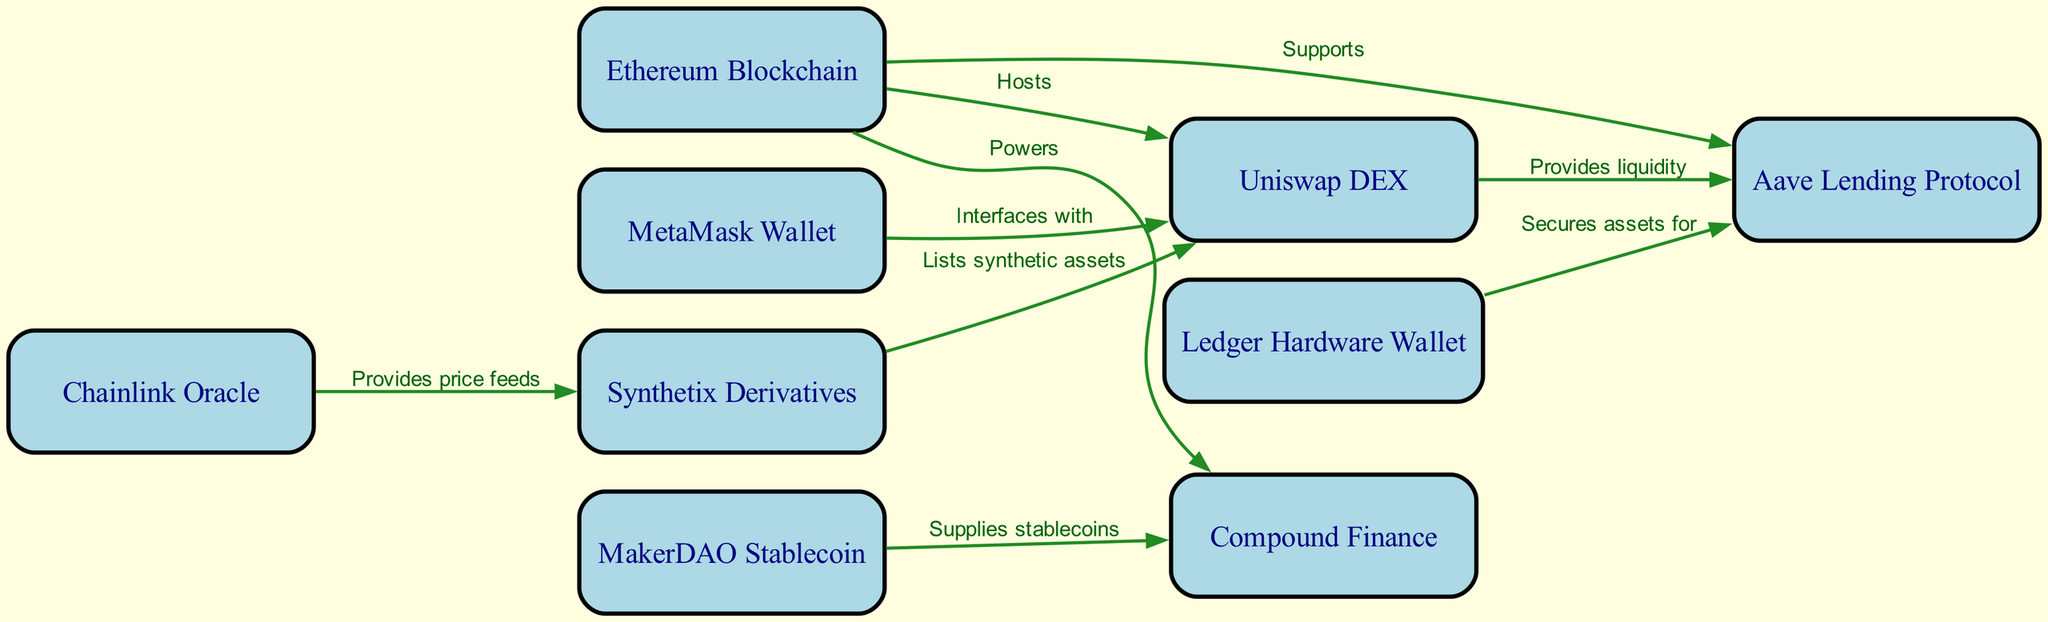What is the total number of nodes in the diagram? The diagram lists a total of 9 distinct entities, each representing different components within the decentralized finance ecosystem, categorized as nodes.
Answer: 9 Which node hosts Uniswap? The diagram clearly labels that the Ethereum Blockchain node hosts the Uniswap DEX, indicating its foundational role in the network.
Answer: Ethereum Blockchain What relationship does Aave have with Ethereum? The diagram connects Aave Lending Protocol to Ethereum with the label "Supports," indicating that Aave operates within the Ethereum blockchain ecosystem.
Answer: Supports How many edges are connecting Uniswap to other nodes? There are 3 distinct edges connecting Uniswap to other nodes: it interacts with MetaMask, provides liquidity to Aave, and lists synthetic assets from Synthetix.
Answer: 3 Which wallet secures assets for Aave? The Ledger Hardware Wallet is specified in the diagram as the entity that secures user assets for Aave, showing its role in safeguarding financial resources.
Answer: Ledger Hardware Wallet What does Chainlink provide to Synthetix? According to the diagram, Chainlink acts as an oracle and provides price feeds to Synthetix, emphasizing the importance of accurate data for derivative trading.
Answer: Price feeds Which DeFi protocol supplies stablecoins to Compound? The diagram indicates that MakerDAO is the protocol that supplies stablecoins to Compound Finance, establishing a direct financial relationship between the two.
Answer: MakerDAO Stablecoin Explain the flow from Synthetix to Uniswap? The diagram shows that Synthetix lists synthetic assets, which implies that these assets can be traded on the Uniswap DEX. This establishes a flow where Synthetix users can use Uniswap for trading.
Answer: Lists synthetic assets How many different types of wallets are shown in the diagram? The diagram shows two types of wallets: MetaMask and Ledger, highlighting the variation in wallet types within the DeFi ecosystem for asset management.
Answer: 2 